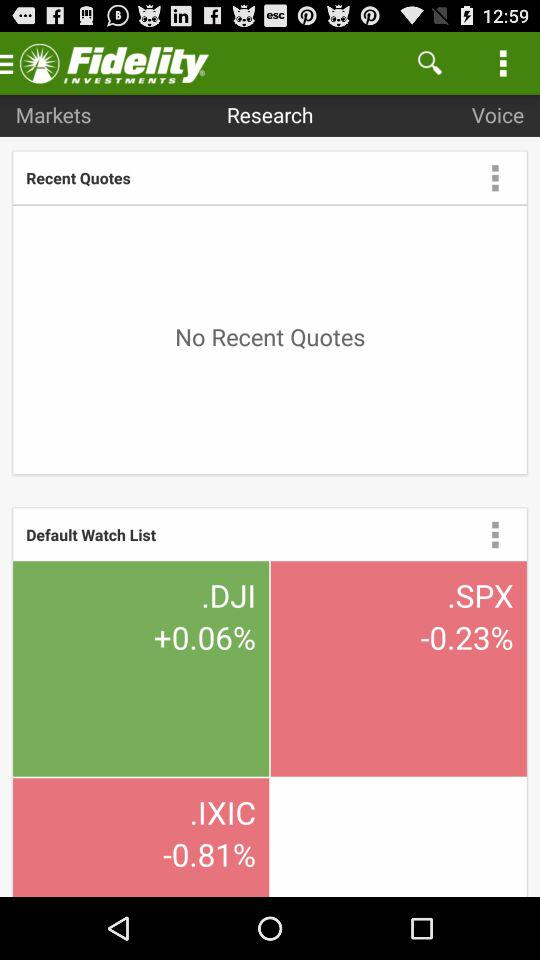What is the percentage change in.SPX? The percentage change in.SPX is -0.23. 